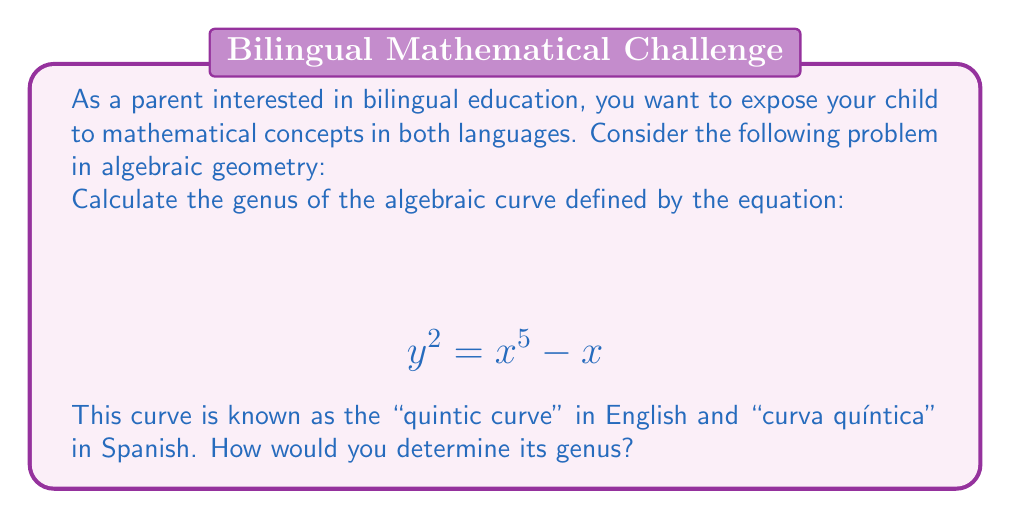What is the answer to this math problem? To calculate the genus of this algebraic curve, we'll follow these steps:

1. Identify the degree of the curve:
   The curve is defined by $y^2 = x^5 - x$, which can be rewritten as $y^2 - x^5 + x = 0$. The highest degree term is $x^5$, so the degree $d = 5$.

2. Check for singularities:
   To find singularities, we need to solve the system of equations:
   $$ \frac{\partial F}{\partial x} = -5x^4 + 1 = 0 $$
   $$ \frac{\partial F}{\partial y} = 2y = 0 $$
   $$ F(x,y) = y^2 - x^5 + x = 0 $$

   Solving this system, we find that there are no finite singularities.

3. Check for singularities at infinity:
   The highest degree terms are $y^2$ and $x^5$, which are relatively prime. This means there are no singularities at infinity.

4. Apply the genus formula for a non-singular plane curve:
   The genus $g$ of a non-singular plane curve of degree $d$ is given by:
   $$ g = \frac{(d-1)(d-2)}{2} $$

5. Calculate the genus:
   Substituting $d = 5$ into the formula:
   $$ g = \frac{(5-1)(5-2)}{2} = \frac{4 \cdot 3}{2} = 6 $$

Therefore, the genus of the given quintic curve is 6.
Answer: 6 